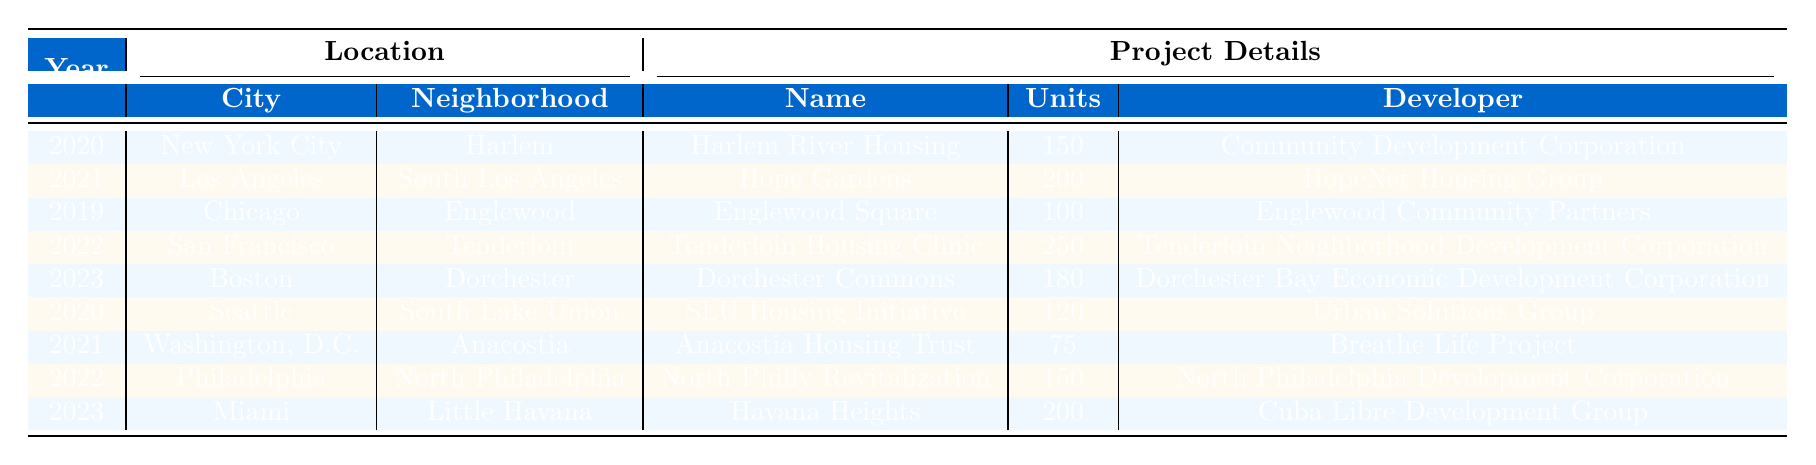What is the name of the affordable housing project in San Francisco? The table lists the projects along with their names. The project in San Francisco for the year 2022 is called "Tenderloin Housing Clinic."
Answer: Tenderloin Housing Clinic How many units are there in the "Hope Gardens" project? According to the table, the "Hope Gardens" project in Los Angeles from 2021 has a total of 200 units.
Answer: 200 Which city has the most recent housing project according to the table? The most recent year in the table is 2023, and the project listed for this year is in Boston, indicating Boston has the most recent housing project.
Answer: Boston What is the total number of units built across all projects listed for the year 2022? For the year 2022, there are two projects: "Tenderloin Housing Clinic" with 250 units and "North Philly Revitalization" with 150 units. Summing them gives 250 + 150 = 400 units.
Answer: 400 Have there been any affordable housing projects in Chicago after 2019? According to the table, the only project listed in Chicago is "Englewood Square," which is from 2019, and there are no subsequent projects in the years 2020, 2021, or 2022 in Chicago. Therefore, the answer is no.
Answer: No Which funding source is used for the "Havana Heights" project? The funding source for the "Havana Heights" project in Miami from the year 2023 is listed as "Federal Affordable Housing Grants."
Answer: Federal Affordable Housing Grants What is the average number of units per project for the year 2021? In 2021, there are two projects: "Hope Gardens" with 200 units and "Anacostia Housing Trust" with 75 units. Summing them gives 200 + 75 = 275 units. Dividing this total by the two projects gives an average of 275 / 2 = 137.5 units.
Answer: 137.5 Which neighborhood in New York City is associated with an affordable housing project? The table indicates that the affordable housing project in New York City is located in Harlem.
Answer: Harlem How many projects were developed in 2020? The table shows two projects for the year 2020: "Harlem River Housing" in New York City and "SLU Housing Initiative" in Seattle. Therefore, there are two developments in 2020.
Answer: 2 Is the developer for the "North Philly Revitalization" project mentioned in the table? The table does include the name of the developer for "North Philly Revitalization," which is "North Philadelphia Development Corporation." Thus, the answer is yes.
Answer: Yes 